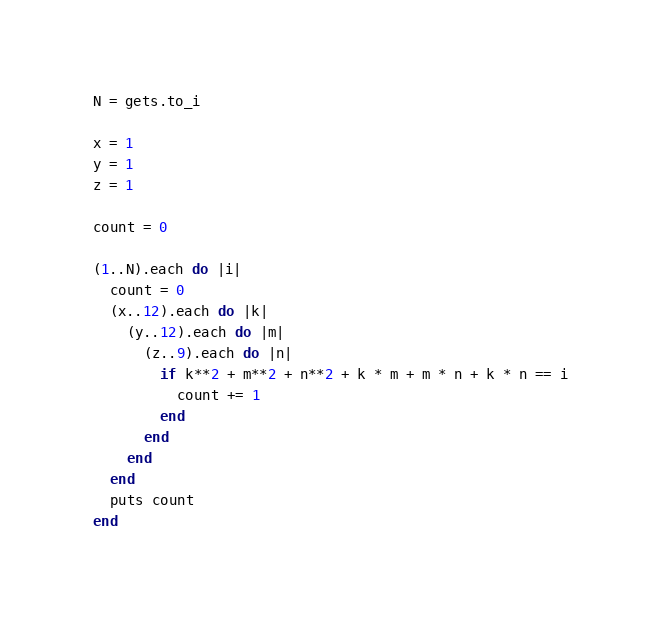Convert code to text. <code><loc_0><loc_0><loc_500><loc_500><_Ruby_>N = gets.to_i
 
x = 1
y = 1
z = 1
 
count = 0
 
(1..N).each do |i|
  count = 0
  (x..12).each do |k|
    (y..12).each do |m|
      (z..9).each do |n|
        if k**2 + m**2 + n**2 + k * m + m * n + k * n == i
          count += 1
        end 
      end
    end
  end
  puts count 
end</code> 